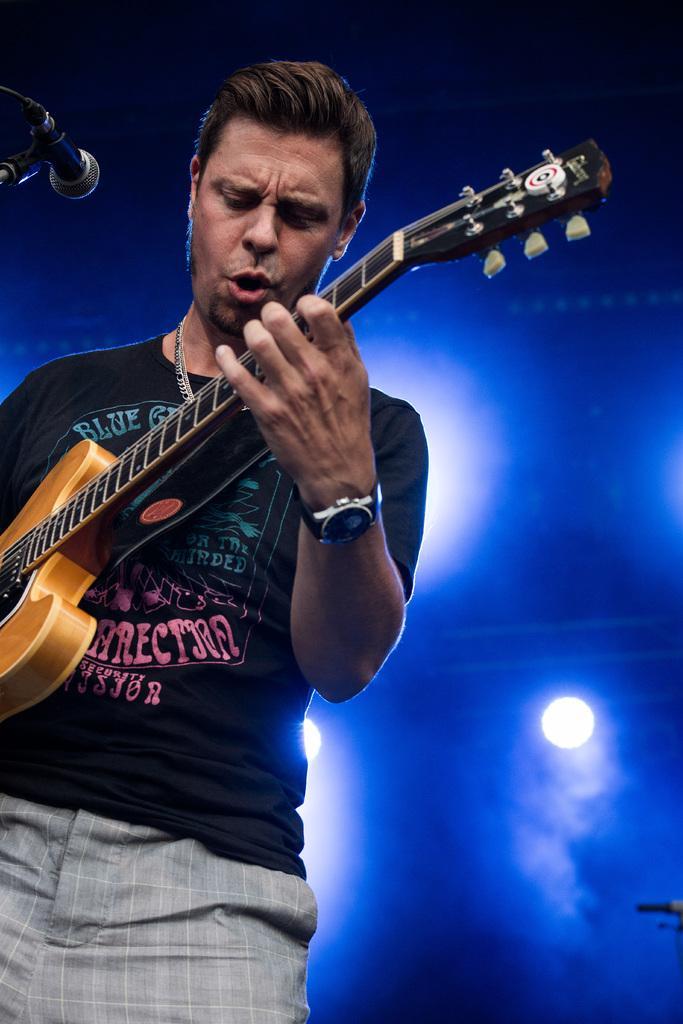Could you give a brief overview of what you see in this image? A man with black t-shirt is standing and playing guitar. In front of him there is a mic, he is singing. To his left hand there is a watch. In the background there are some lights. 